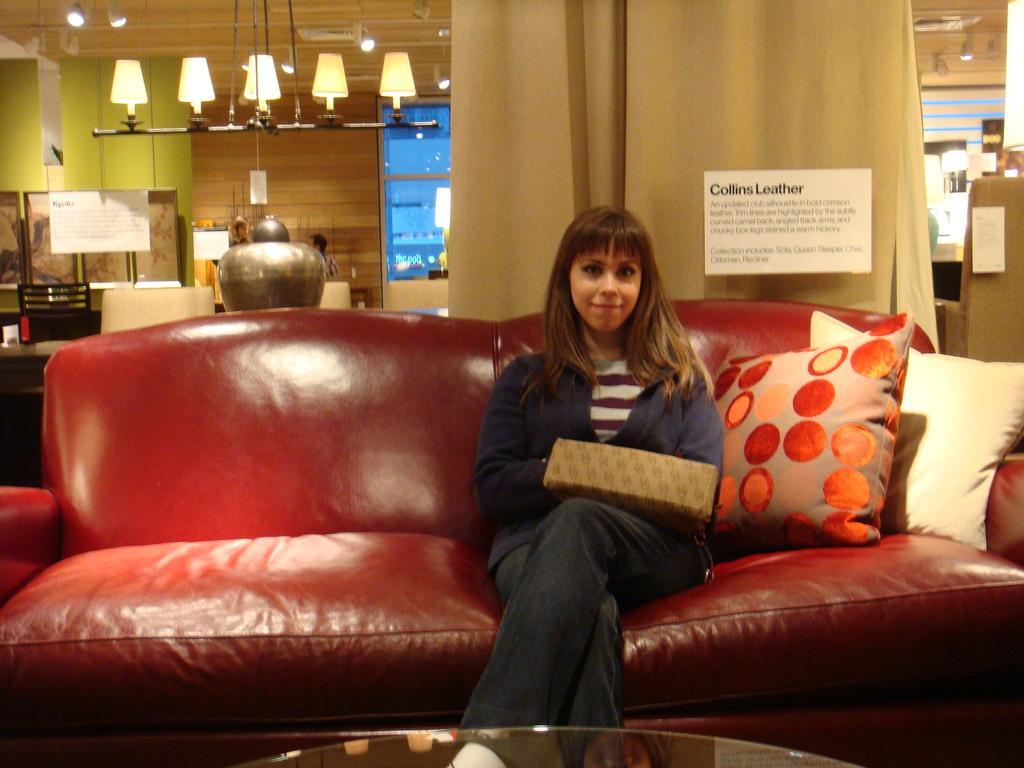In one or two sentences, can you explain what this image depicts? This woman is sitting on a red couch with pillows. This is curtain. Far there are lights. On a wall there is a poster. This is chair. This woman is holding a handbag. 